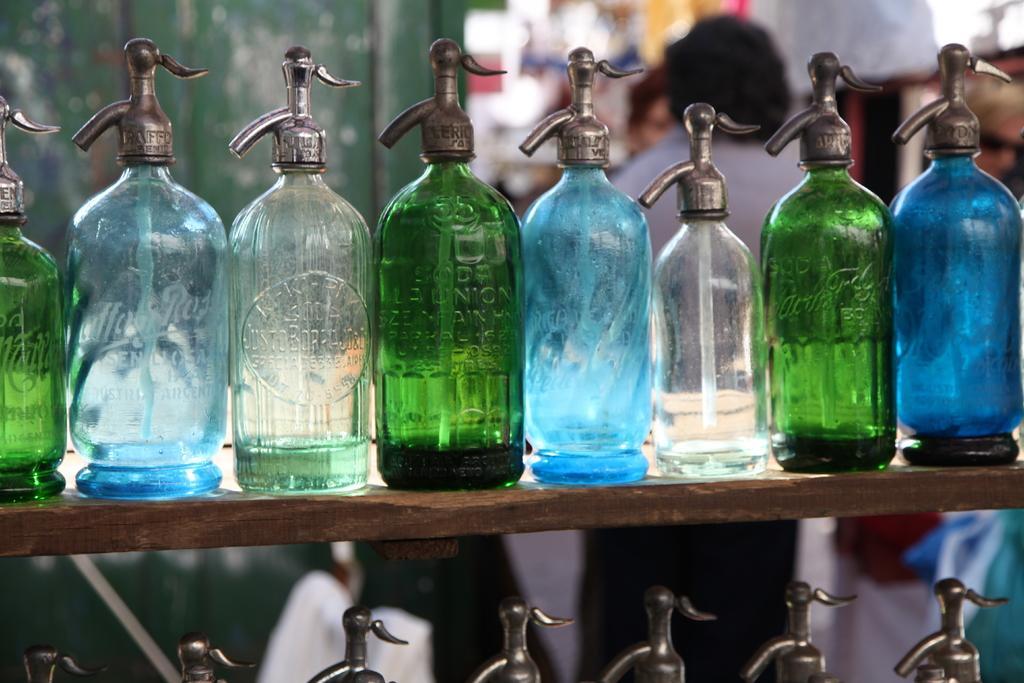How would you summarize this image in a sentence or two? In this picture there are many bottles which are blue and green in color. There is a person. There is a wooden fence. 